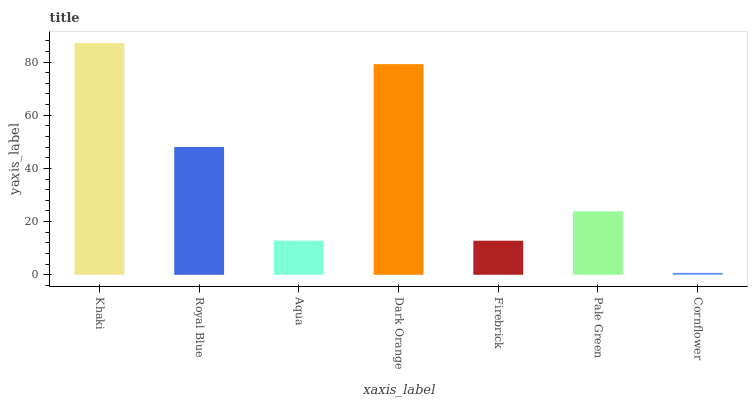Is Royal Blue the minimum?
Answer yes or no. No. Is Royal Blue the maximum?
Answer yes or no. No. Is Khaki greater than Royal Blue?
Answer yes or no. Yes. Is Royal Blue less than Khaki?
Answer yes or no. Yes. Is Royal Blue greater than Khaki?
Answer yes or no. No. Is Khaki less than Royal Blue?
Answer yes or no. No. Is Pale Green the high median?
Answer yes or no. Yes. Is Pale Green the low median?
Answer yes or no. Yes. Is Aqua the high median?
Answer yes or no. No. Is Cornflower the low median?
Answer yes or no. No. 